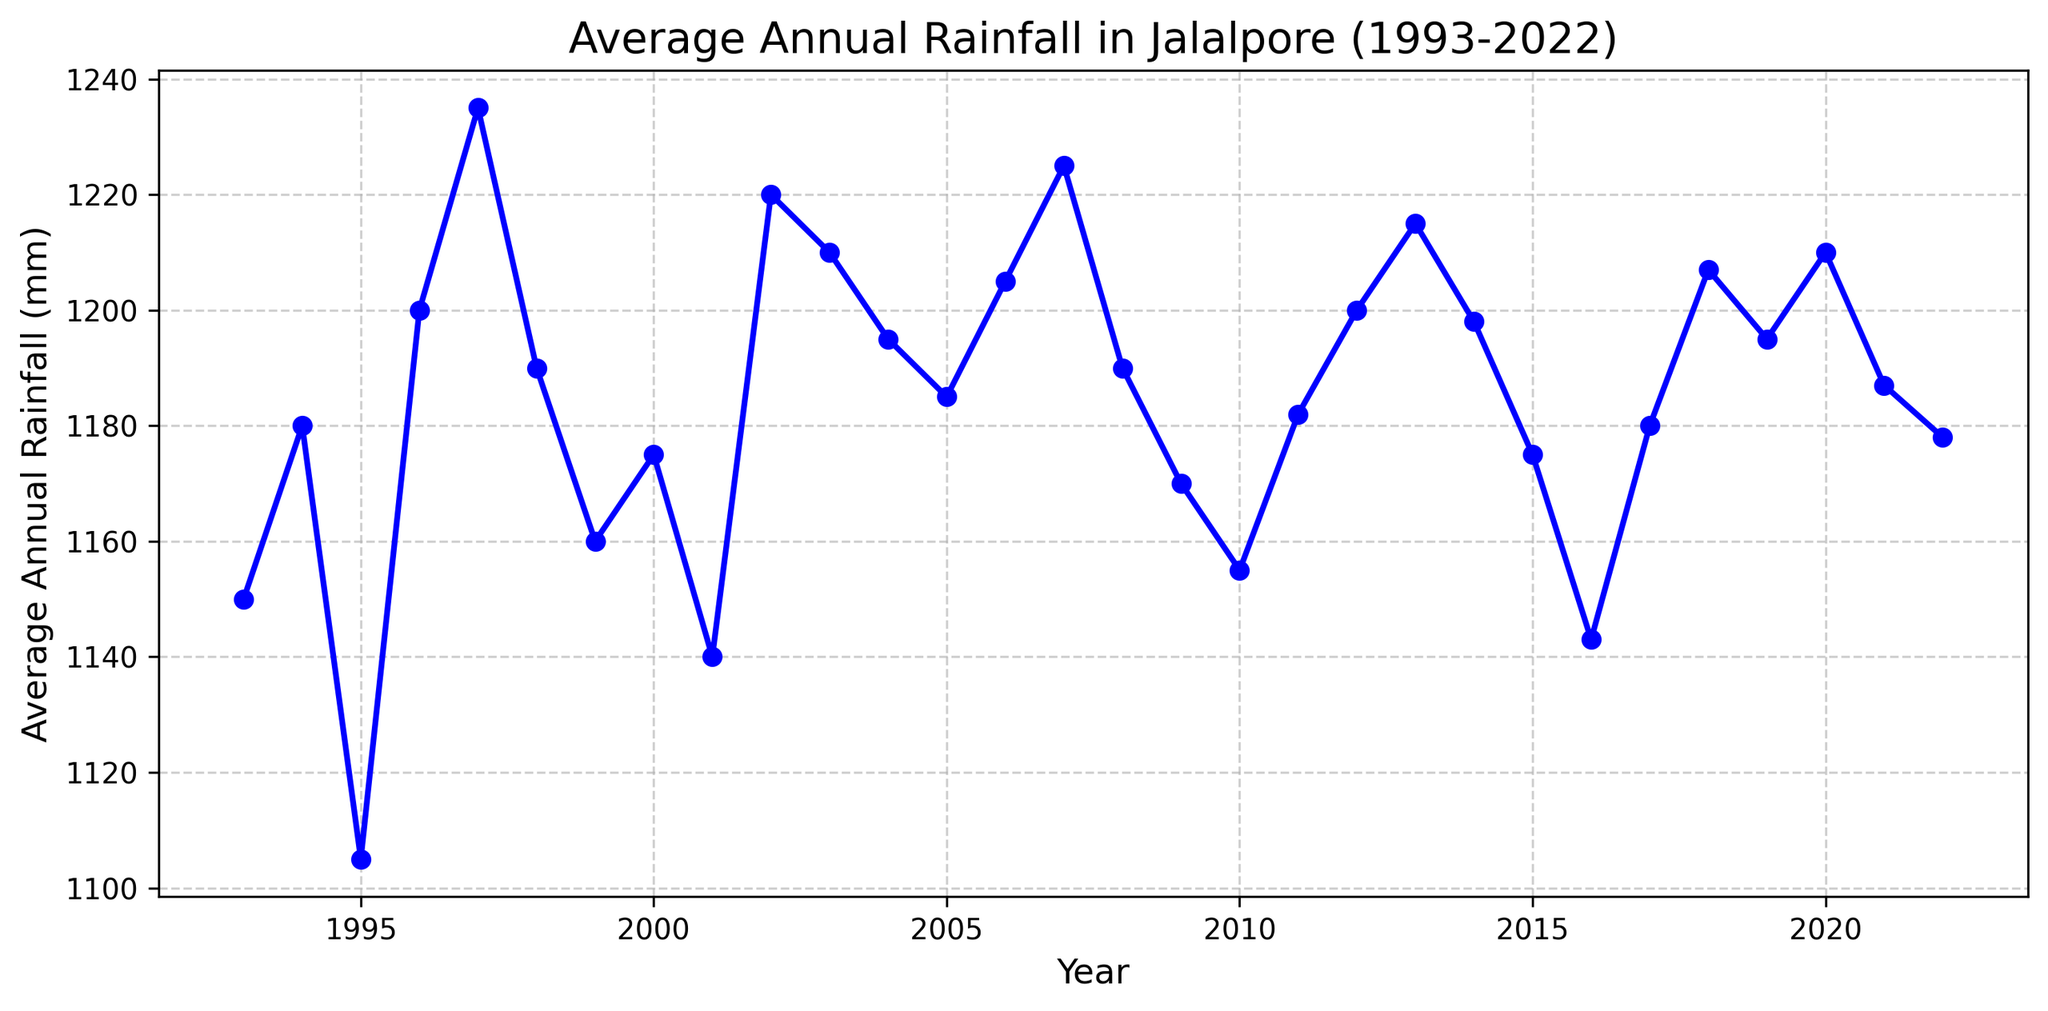What's the overall trend in average annual rainfall from 1993 to 2022? By examining the line plot from 1993 to 2022, we observe the general movement of the line to determine if the average annual rainfall is increasing, decreasing, or stable. The trend appears relatively stable with slight fluctuations over time.
Answer: Relatively stable with slight fluctuations What was the year with the highest average annual rainfall? By looking for the peak point on the line graph, the highest data point corresponds to the year with the maximum rainfall. The peak occurs in 1997 with 1235 mm.
Answer: 1997 Compare the average annual rainfall in 2002 and 2003. Which year had higher rainfall? Identify the rainfall values for 2002 (1220 mm) and 2003 (1210 mm) and compare them. 2002 had higher rainfall.
Answer: 2002 What is the average of the average annual rainfall for the first five years (1993-1997)? To find the average, sum the rainfall values for the years 1993 (1150), 1994 (1180), 1995 (1105), 1996 (1200), and 1997 (1235), then divide by 5. (1150 + 1180 + 1105 + 1200 + 1235) / 5 = 1174 mm
Answer: 1174 mm How did the rainfall in 2014 compare to that in 2015? Locate and compare the rainfall values for 2014 (1198 mm) and 2015 (1175 mm). 2014 had more rainfall than 2015.
Answer: 2014 What is the range of average annual rainfall over these 30 years? Identify the maximum and minimum rainfall values: max is 1235 mm (1997), and min is 1105 mm (1995). Calculate the range by subtracting the minimum from the maximum. 1235 - 1105 = 130 mm
Answer: 130 mm How many years had an average annual rainfall of more than 1200 mm? Count the number of data points where the annual rainfall is above 1200. The years are 1996, 1997, 2002, 2007, 2010, 2012, 2013, and 2020. There are 8 such years.
Answer: 8 Did the average annual rainfall in 2010 increase or decrease compared to 2009, and by how much? Find the rainfall for 2009 (1170 mm) and 2010 (1155 mm). Subtract 2009's value from 2010's value: 1155 - 1170 = -15 mm, indicating a decrease.
Answer: Decrease by 15 mm What is the median value of the annual rainfall over the years? Arrange the rainfall values from least to greatest and find the middle value of the 30 data points. The middle points are the 15th and 16th values (both 1195 mm and 1198 mm), thus the median is (1195 + 1198) / 2 = 1196.5 mm.
Answer: 1196.5 mm 